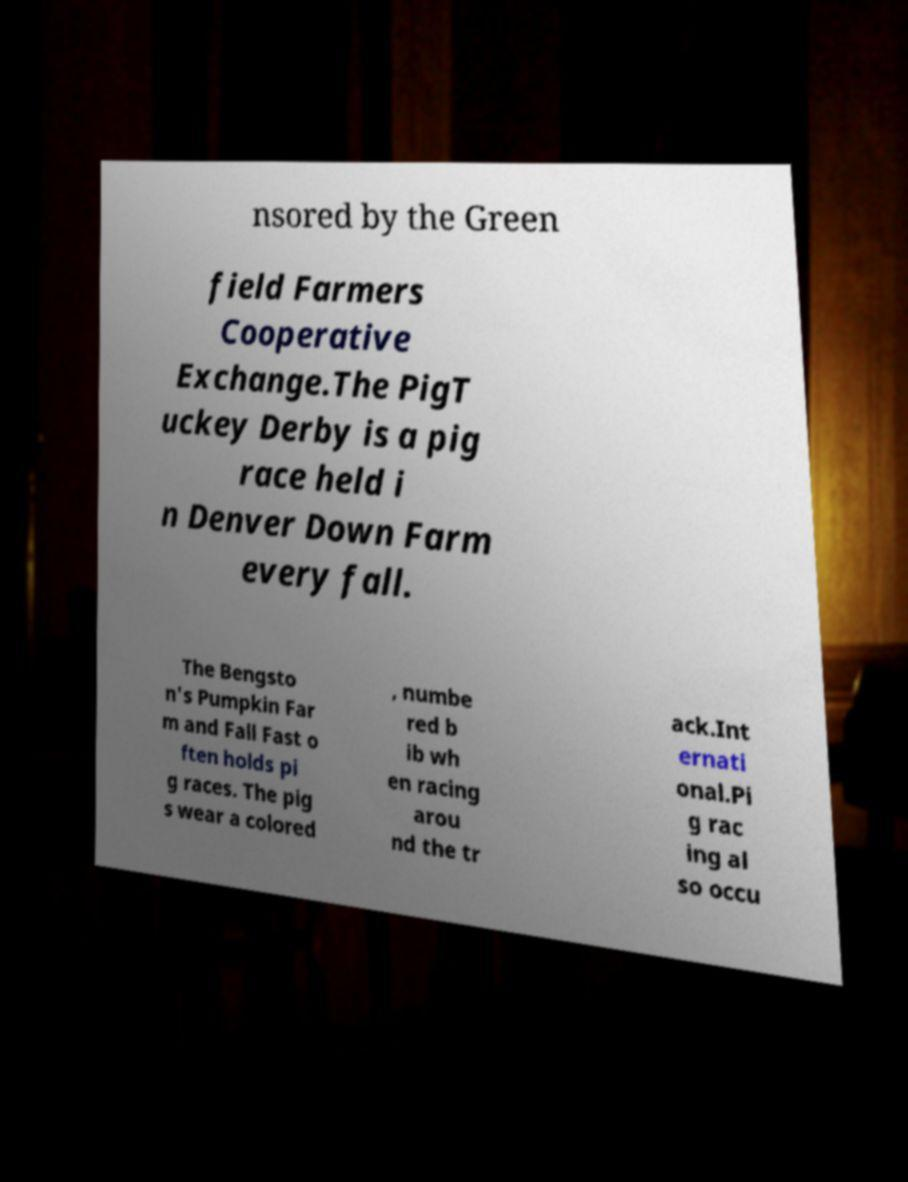Please read and relay the text visible in this image. What does it say? nsored by the Green field Farmers Cooperative Exchange.The PigT uckey Derby is a pig race held i n Denver Down Farm every fall. The Bengsto n's Pumpkin Far m and Fall Fast o ften holds pi g races. The pig s wear a colored , numbe red b ib wh en racing arou nd the tr ack.Int ernati onal.Pi g rac ing al so occu 